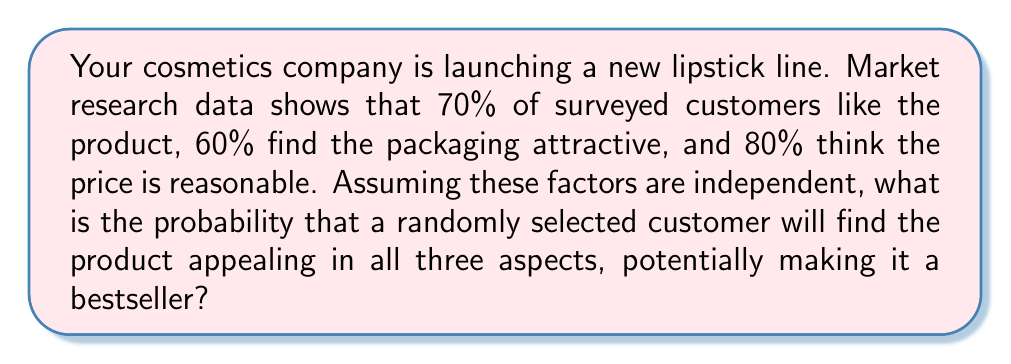Teach me how to tackle this problem. To solve this problem, we need to use the multiplication rule for independent events. The probability of all three events occurring simultaneously is the product of their individual probabilities.

Let's define our events:
A: Customer likes the product (P(A) = 0.70)
B: Customer finds the packaging attractive (P(B) = 0.60)
C: Customer thinks the price is reasonable (P(C) = 0.80)

We want to find P(A ∩ B ∩ C), which is the probability of all three events occurring together.

Since the events are independent:

$$P(A \cap B \cap C) = P(A) \times P(B) \times P(C)$$

Substituting the values:

$$P(A \cap B \cap C) = 0.70 \times 0.60 \times 0.80$$

Calculating:

$$P(A \cap B \cap C) = 0.336$$

Therefore, the probability that a randomly selected customer will find the product appealing in all three aspects is 0.336 or 33.6%.
Answer: 0.336 or 33.6% 